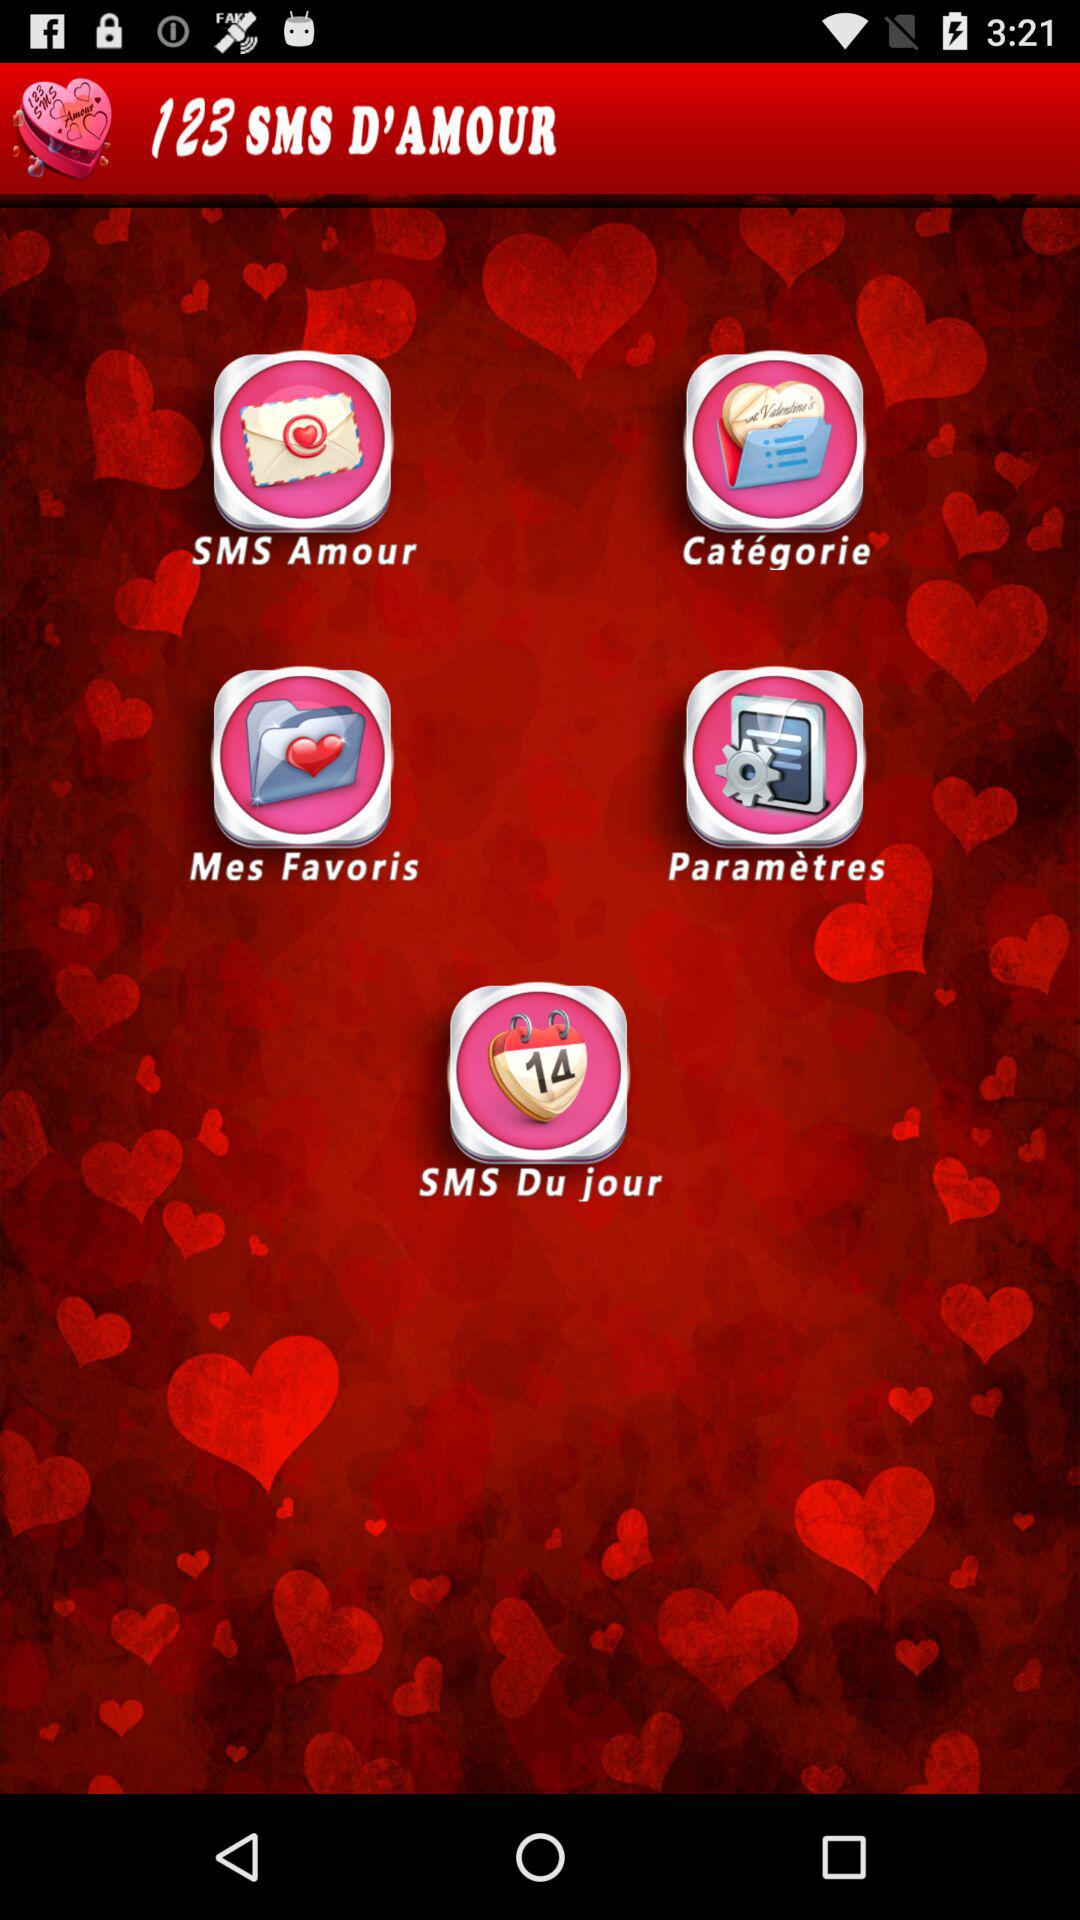What is the name of the application? The name of the application is "123 SMS D'AMOUR". 